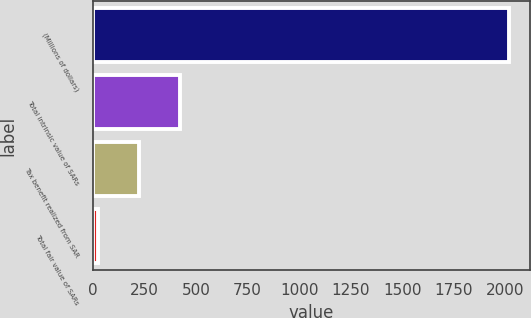<chart> <loc_0><loc_0><loc_500><loc_500><bar_chart><fcel>(Millions of dollars)<fcel>Total intrinsic value of SARs<fcel>Tax benefit realized from SAR<fcel>Total fair value of SARs<nl><fcel>2016<fcel>422.4<fcel>223.2<fcel>24<nl></chart> 